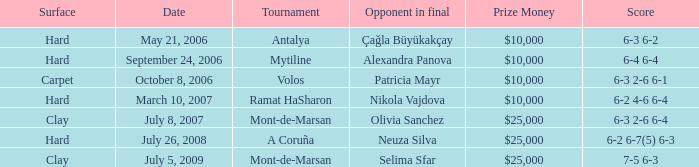What is the date of the match on clay with score of 6-3 2-6 6-4? July 8, 2007. 